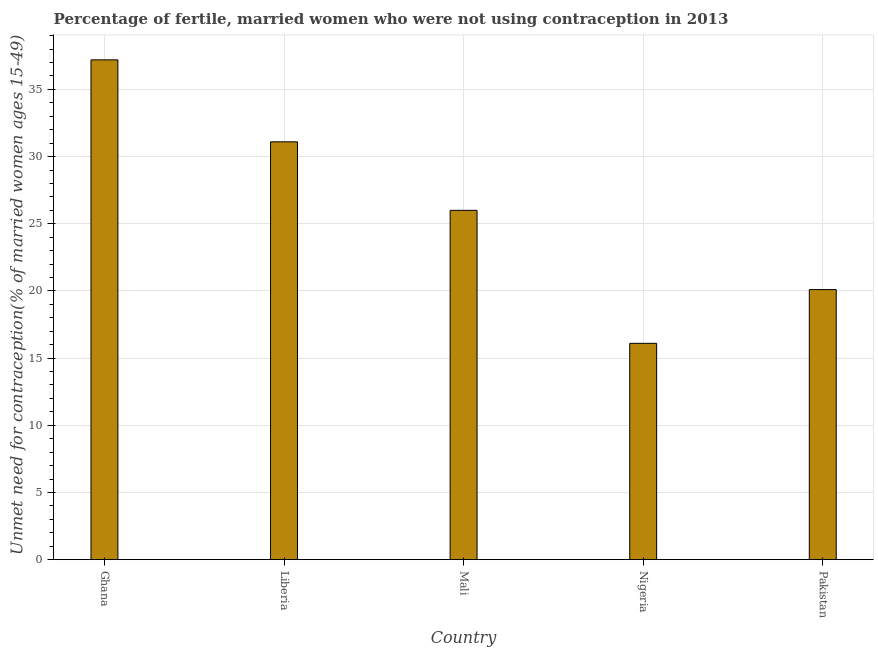Does the graph contain any zero values?
Make the answer very short. No. What is the title of the graph?
Ensure brevity in your answer.  Percentage of fertile, married women who were not using contraception in 2013. What is the label or title of the X-axis?
Your answer should be very brief. Country. What is the label or title of the Y-axis?
Offer a very short reply.  Unmet need for contraception(% of married women ages 15-49). What is the number of married women who are not using contraception in Pakistan?
Keep it short and to the point. 20.1. Across all countries, what is the maximum number of married women who are not using contraception?
Provide a succinct answer. 37.2. Across all countries, what is the minimum number of married women who are not using contraception?
Make the answer very short. 16.1. In which country was the number of married women who are not using contraception minimum?
Your response must be concise. Nigeria. What is the sum of the number of married women who are not using contraception?
Give a very brief answer. 130.5. What is the average number of married women who are not using contraception per country?
Give a very brief answer. 26.1. What is the ratio of the number of married women who are not using contraception in Ghana to that in Liberia?
Your answer should be compact. 1.2. Is the difference between the number of married women who are not using contraception in Ghana and Mali greater than the difference between any two countries?
Make the answer very short. No. What is the difference between the highest and the second highest number of married women who are not using contraception?
Offer a very short reply. 6.1. Is the sum of the number of married women who are not using contraception in Nigeria and Pakistan greater than the maximum number of married women who are not using contraception across all countries?
Provide a short and direct response. No. What is the difference between the highest and the lowest number of married women who are not using contraception?
Give a very brief answer. 21.1. Are all the bars in the graph horizontal?
Provide a short and direct response. No. How many countries are there in the graph?
Provide a succinct answer. 5. Are the values on the major ticks of Y-axis written in scientific E-notation?
Provide a succinct answer. No. What is the  Unmet need for contraception(% of married women ages 15-49) in Ghana?
Your response must be concise. 37.2. What is the  Unmet need for contraception(% of married women ages 15-49) in Liberia?
Offer a terse response. 31.1. What is the  Unmet need for contraception(% of married women ages 15-49) in Mali?
Offer a terse response. 26. What is the  Unmet need for contraception(% of married women ages 15-49) of Nigeria?
Your answer should be compact. 16.1. What is the  Unmet need for contraception(% of married women ages 15-49) in Pakistan?
Provide a short and direct response. 20.1. What is the difference between the  Unmet need for contraception(% of married women ages 15-49) in Ghana and Liberia?
Offer a terse response. 6.1. What is the difference between the  Unmet need for contraception(% of married women ages 15-49) in Ghana and Nigeria?
Give a very brief answer. 21.1. What is the difference between the  Unmet need for contraception(% of married women ages 15-49) in Liberia and Pakistan?
Your response must be concise. 11. What is the difference between the  Unmet need for contraception(% of married women ages 15-49) in Mali and Nigeria?
Your answer should be compact. 9.9. What is the difference between the  Unmet need for contraception(% of married women ages 15-49) in Mali and Pakistan?
Offer a terse response. 5.9. What is the ratio of the  Unmet need for contraception(% of married women ages 15-49) in Ghana to that in Liberia?
Make the answer very short. 1.2. What is the ratio of the  Unmet need for contraception(% of married women ages 15-49) in Ghana to that in Mali?
Offer a terse response. 1.43. What is the ratio of the  Unmet need for contraception(% of married women ages 15-49) in Ghana to that in Nigeria?
Make the answer very short. 2.31. What is the ratio of the  Unmet need for contraception(% of married women ages 15-49) in Ghana to that in Pakistan?
Your answer should be compact. 1.85. What is the ratio of the  Unmet need for contraception(% of married women ages 15-49) in Liberia to that in Mali?
Your answer should be very brief. 1.2. What is the ratio of the  Unmet need for contraception(% of married women ages 15-49) in Liberia to that in Nigeria?
Your answer should be compact. 1.93. What is the ratio of the  Unmet need for contraception(% of married women ages 15-49) in Liberia to that in Pakistan?
Your response must be concise. 1.55. What is the ratio of the  Unmet need for contraception(% of married women ages 15-49) in Mali to that in Nigeria?
Provide a short and direct response. 1.61. What is the ratio of the  Unmet need for contraception(% of married women ages 15-49) in Mali to that in Pakistan?
Offer a terse response. 1.29. What is the ratio of the  Unmet need for contraception(% of married women ages 15-49) in Nigeria to that in Pakistan?
Your answer should be very brief. 0.8. 